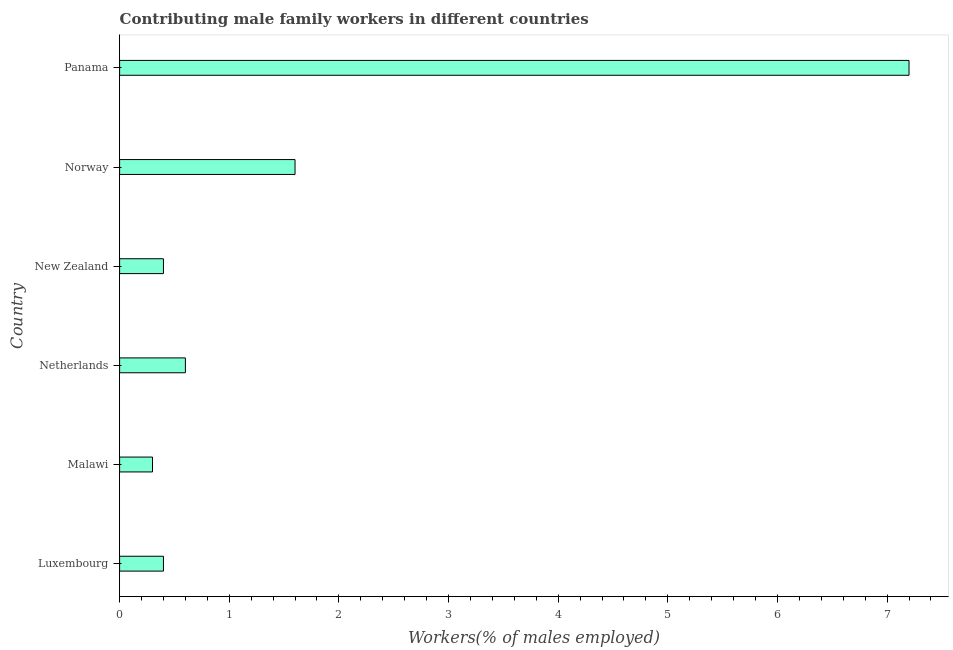Does the graph contain any zero values?
Your answer should be very brief. No. What is the title of the graph?
Offer a very short reply. Contributing male family workers in different countries. What is the label or title of the X-axis?
Keep it short and to the point. Workers(% of males employed). What is the label or title of the Y-axis?
Give a very brief answer. Country. What is the contributing male family workers in Norway?
Make the answer very short. 1.6. Across all countries, what is the maximum contributing male family workers?
Offer a very short reply. 7.2. Across all countries, what is the minimum contributing male family workers?
Make the answer very short. 0.3. In which country was the contributing male family workers maximum?
Your answer should be very brief. Panama. In which country was the contributing male family workers minimum?
Your answer should be compact. Malawi. What is the sum of the contributing male family workers?
Your answer should be very brief. 10.5. What is the average contributing male family workers per country?
Offer a very short reply. 1.75. What is the median contributing male family workers?
Your answer should be compact. 0.5. In how many countries, is the contributing male family workers greater than 1.2 %?
Make the answer very short. 2. What is the ratio of the contributing male family workers in Malawi to that in Norway?
Give a very brief answer. 0.19. Is the contributing male family workers in Luxembourg less than that in Netherlands?
Your answer should be very brief. Yes. Is the difference between the contributing male family workers in Luxembourg and Norway greater than the difference between any two countries?
Your answer should be very brief. No. What is the difference between the highest and the lowest contributing male family workers?
Offer a terse response. 6.9. In how many countries, is the contributing male family workers greater than the average contributing male family workers taken over all countries?
Make the answer very short. 1. How many bars are there?
Offer a terse response. 6. Are the values on the major ticks of X-axis written in scientific E-notation?
Give a very brief answer. No. What is the Workers(% of males employed) in Luxembourg?
Keep it short and to the point. 0.4. What is the Workers(% of males employed) in Malawi?
Your response must be concise. 0.3. What is the Workers(% of males employed) in Netherlands?
Provide a succinct answer. 0.6. What is the Workers(% of males employed) of New Zealand?
Your response must be concise. 0.4. What is the Workers(% of males employed) in Norway?
Offer a very short reply. 1.6. What is the Workers(% of males employed) in Panama?
Offer a very short reply. 7.2. What is the difference between the Workers(% of males employed) in Luxembourg and New Zealand?
Your answer should be compact. 0. What is the difference between the Workers(% of males employed) in Luxembourg and Norway?
Make the answer very short. -1.2. What is the difference between the Workers(% of males employed) in Malawi and Netherlands?
Provide a succinct answer. -0.3. What is the difference between the Workers(% of males employed) in Netherlands and New Zealand?
Your answer should be very brief. 0.2. What is the difference between the Workers(% of males employed) in New Zealand and Norway?
Keep it short and to the point. -1.2. What is the difference between the Workers(% of males employed) in New Zealand and Panama?
Provide a short and direct response. -6.8. What is the difference between the Workers(% of males employed) in Norway and Panama?
Provide a succinct answer. -5.6. What is the ratio of the Workers(% of males employed) in Luxembourg to that in Malawi?
Give a very brief answer. 1.33. What is the ratio of the Workers(% of males employed) in Luxembourg to that in Netherlands?
Provide a succinct answer. 0.67. What is the ratio of the Workers(% of males employed) in Luxembourg to that in New Zealand?
Your answer should be compact. 1. What is the ratio of the Workers(% of males employed) in Luxembourg to that in Norway?
Your response must be concise. 0.25. What is the ratio of the Workers(% of males employed) in Luxembourg to that in Panama?
Your answer should be compact. 0.06. What is the ratio of the Workers(% of males employed) in Malawi to that in Norway?
Offer a terse response. 0.19. What is the ratio of the Workers(% of males employed) in Malawi to that in Panama?
Give a very brief answer. 0.04. What is the ratio of the Workers(% of males employed) in Netherlands to that in Norway?
Provide a short and direct response. 0.38. What is the ratio of the Workers(% of males employed) in Netherlands to that in Panama?
Your answer should be compact. 0.08. What is the ratio of the Workers(% of males employed) in New Zealand to that in Panama?
Give a very brief answer. 0.06. What is the ratio of the Workers(% of males employed) in Norway to that in Panama?
Offer a terse response. 0.22. 